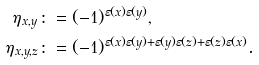<formula> <loc_0><loc_0><loc_500><loc_500>\eta _ { x , y } & \colon = ( - 1 ) ^ { \varepsilon ( x ) \varepsilon ( y ) } , \\ \eta _ { x , y , z } & \colon = ( - 1 ) ^ { \varepsilon ( x ) \varepsilon ( y ) + \varepsilon ( y ) \varepsilon ( z ) + \varepsilon ( z ) \varepsilon ( x ) } .</formula> 